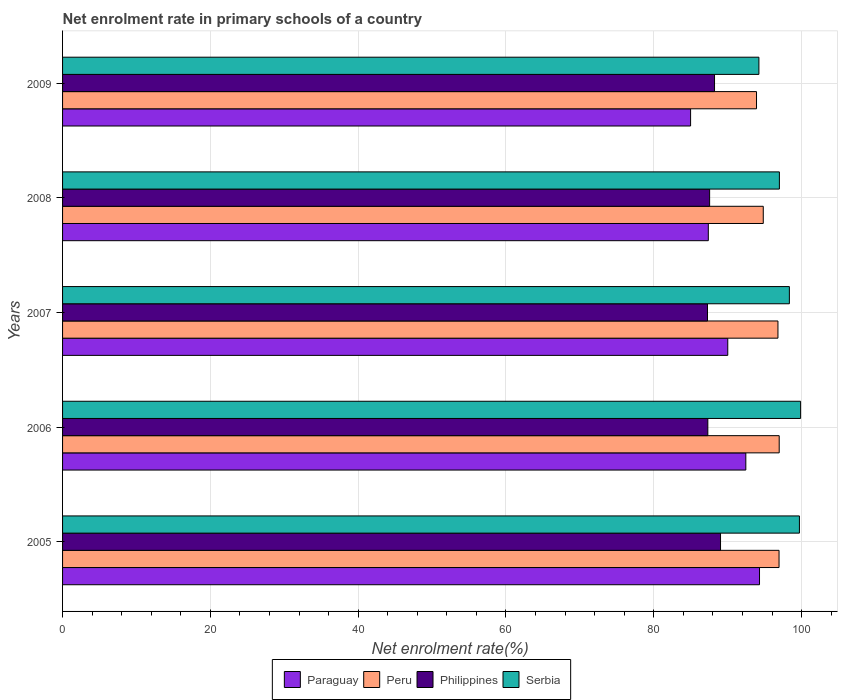Are the number of bars per tick equal to the number of legend labels?
Your answer should be very brief. Yes. How many bars are there on the 3rd tick from the bottom?
Your response must be concise. 4. In how many cases, is the number of bars for a given year not equal to the number of legend labels?
Give a very brief answer. 0. What is the net enrolment rate in primary schools in Peru in 2007?
Your answer should be very brief. 96.8. Across all years, what is the maximum net enrolment rate in primary schools in Paraguay?
Offer a very short reply. 94.3. Across all years, what is the minimum net enrolment rate in primary schools in Philippines?
Your answer should be compact. 87.27. In which year was the net enrolment rate in primary schools in Paraguay maximum?
Offer a terse response. 2005. What is the total net enrolment rate in primary schools in Peru in the graph?
Give a very brief answer. 479.43. What is the difference between the net enrolment rate in primary schools in Philippines in 2005 and that in 2008?
Offer a very short reply. 1.47. What is the difference between the net enrolment rate in primary schools in Peru in 2005 and the net enrolment rate in primary schools in Philippines in 2008?
Provide a short and direct response. 9.39. What is the average net enrolment rate in primary schools in Paraguay per year?
Offer a terse response. 89.82. In the year 2006, what is the difference between the net enrolment rate in primary schools in Paraguay and net enrolment rate in primary schools in Peru?
Your response must be concise. -4.51. What is the ratio of the net enrolment rate in primary schools in Paraguay in 2006 to that in 2008?
Provide a succinct answer. 1.06. Is the difference between the net enrolment rate in primary schools in Paraguay in 2005 and 2006 greater than the difference between the net enrolment rate in primary schools in Peru in 2005 and 2006?
Offer a terse response. Yes. What is the difference between the highest and the second highest net enrolment rate in primary schools in Philippines?
Provide a short and direct response. 0.81. What is the difference between the highest and the lowest net enrolment rate in primary schools in Paraguay?
Offer a very short reply. 9.32. What does the 4th bar from the top in 2009 represents?
Your answer should be very brief. Paraguay. Is it the case that in every year, the sum of the net enrolment rate in primary schools in Philippines and net enrolment rate in primary schools in Paraguay is greater than the net enrolment rate in primary schools in Serbia?
Keep it short and to the point. Yes. How many bars are there?
Your response must be concise. 20. What is the difference between two consecutive major ticks on the X-axis?
Keep it short and to the point. 20. Does the graph contain any zero values?
Offer a terse response. No. Does the graph contain grids?
Your response must be concise. Yes. How many legend labels are there?
Make the answer very short. 4. What is the title of the graph?
Offer a terse response. Net enrolment rate in primary schools of a country. What is the label or title of the X-axis?
Offer a terse response. Net enrolment rate(%). What is the label or title of the Y-axis?
Your answer should be very brief. Years. What is the Net enrolment rate(%) in Paraguay in 2005?
Ensure brevity in your answer.  94.3. What is the Net enrolment rate(%) in Peru in 2005?
Your answer should be very brief. 96.95. What is the Net enrolment rate(%) in Philippines in 2005?
Give a very brief answer. 89.03. What is the Net enrolment rate(%) in Serbia in 2005?
Provide a short and direct response. 99.7. What is the Net enrolment rate(%) in Paraguay in 2006?
Offer a terse response. 92.45. What is the Net enrolment rate(%) of Peru in 2006?
Provide a short and direct response. 96.97. What is the Net enrolment rate(%) in Philippines in 2006?
Offer a very short reply. 87.31. What is the Net enrolment rate(%) in Serbia in 2006?
Your response must be concise. 99.86. What is the Net enrolment rate(%) of Paraguay in 2007?
Your response must be concise. 90.01. What is the Net enrolment rate(%) in Peru in 2007?
Provide a succinct answer. 96.8. What is the Net enrolment rate(%) in Philippines in 2007?
Ensure brevity in your answer.  87.27. What is the Net enrolment rate(%) in Serbia in 2007?
Ensure brevity in your answer.  98.34. What is the Net enrolment rate(%) in Paraguay in 2008?
Keep it short and to the point. 87.38. What is the Net enrolment rate(%) of Peru in 2008?
Offer a very short reply. 94.81. What is the Net enrolment rate(%) in Philippines in 2008?
Offer a terse response. 87.55. What is the Net enrolment rate(%) of Serbia in 2008?
Provide a short and direct response. 96.99. What is the Net enrolment rate(%) in Paraguay in 2009?
Give a very brief answer. 84.98. What is the Net enrolment rate(%) of Peru in 2009?
Keep it short and to the point. 93.9. What is the Net enrolment rate(%) of Philippines in 2009?
Your response must be concise. 88.22. What is the Net enrolment rate(%) in Serbia in 2009?
Provide a short and direct response. 94.22. Across all years, what is the maximum Net enrolment rate(%) of Paraguay?
Your response must be concise. 94.3. Across all years, what is the maximum Net enrolment rate(%) of Peru?
Ensure brevity in your answer.  96.97. Across all years, what is the maximum Net enrolment rate(%) in Philippines?
Keep it short and to the point. 89.03. Across all years, what is the maximum Net enrolment rate(%) in Serbia?
Give a very brief answer. 99.86. Across all years, what is the minimum Net enrolment rate(%) of Paraguay?
Give a very brief answer. 84.98. Across all years, what is the minimum Net enrolment rate(%) in Peru?
Provide a succinct answer. 93.9. Across all years, what is the minimum Net enrolment rate(%) of Philippines?
Your response must be concise. 87.27. Across all years, what is the minimum Net enrolment rate(%) in Serbia?
Keep it short and to the point. 94.22. What is the total Net enrolment rate(%) in Paraguay in the graph?
Offer a very short reply. 449.12. What is the total Net enrolment rate(%) of Peru in the graph?
Make the answer very short. 479.43. What is the total Net enrolment rate(%) in Philippines in the graph?
Offer a very short reply. 439.38. What is the total Net enrolment rate(%) of Serbia in the graph?
Give a very brief answer. 489.13. What is the difference between the Net enrolment rate(%) of Paraguay in 2005 and that in 2006?
Provide a succinct answer. 1.85. What is the difference between the Net enrolment rate(%) in Peru in 2005 and that in 2006?
Ensure brevity in your answer.  -0.02. What is the difference between the Net enrolment rate(%) in Philippines in 2005 and that in 2006?
Your answer should be very brief. 1.72. What is the difference between the Net enrolment rate(%) of Serbia in 2005 and that in 2006?
Provide a short and direct response. -0.16. What is the difference between the Net enrolment rate(%) in Paraguay in 2005 and that in 2007?
Provide a succinct answer. 4.29. What is the difference between the Net enrolment rate(%) in Peru in 2005 and that in 2007?
Provide a succinct answer. 0.15. What is the difference between the Net enrolment rate(%) of Philippines in 2005 and that in 2007?
Your response must be concise. 1.76. What is the difference between the Net enrolment rate(%) of Serbia in 2005 and that in 2007?
Keep it short and to the point. 1.36. What is the difference between the Net enrolment rate(%) of Paraguay in 2005 and that in 2008?
Ensure brevity in your answer.  6.93. What is the difference between the Net enrolment rate(%) in Peru in 2005 and that in 2008?
Provide a succinct answer. 2.14. What is the difference between the Net enrolment rate(%) of Philippines in 2005 and that in 2008?
Your answer should be very brief. 1.47. What is the difference between the Net enrolment rate(%) in Serbia in 2005 and that in 2008?
Provide a succinct answer. 2.71. What is the difference between the Net enrolment rate(%) of Paraguay in 2005 and that in 2009?
Give a very brief answer. 9.32. What is the difference between the Net enrolment rate(%) in Peru in 2005 and that in 2009?
Make the answer very short. 3.05. What is the difference between the Net enrolment rate(%) of Philippines in 2005 and that in 2009?
Give a very brief answer. 0.81. What is the difference between the Net enrolment rate(%) of Serbia in 2005 and that in 2009?
Offer a very short reply. 5.48. What is the difference between the Net enrolment rate(%) in Paraguay in 2006 and that in 2007?
Offer a terse response. 2.44. What is the difference between the Net enrolment rate(%) of Peru in 2006 and that in 2007?
Give a very brief answer. 0.17. What is the difference between the Net enrolment rate(%) in Philippines in 2006 and that in 2007?
Keep it short and to the point. 0.04. What is the difference between the Net enrolment rate(%) in Serbia in 2006 and that in 2007?
Your response must be concise. 1.52. What is the difference between the Net enrolment rate(%) of Paraguay in 2006 and that in 2008?
Ensure brevity in your answer.  5.08. What is the difference between the Net enrolment rate(%) of Peru in 2006 and that in 2008?
Your answer should be very brief. 2.16. What is the difference between the Net enrolment rate(%) of Philippines in 2006 and that in 2008?
Ensure brevity in your answer.  -0.24. What is the difference between the Net enrolment rate(%) of Serbia in 2006 and that in 2008?
Give a very brief answer. 2.87. What is the difference between the Net enrolment rate(%) in Paraguay in 2006 and that in 2009?
Provide a short and direct response. 7.47. What is the difference between the Net enrolment rate(%) in Peru in 2006 and that in 2009?
Provide a succinct answer. 3.07. What is the difference between the Net enrolment rate(%) in Philippines in 2006 and that in 2009?
Your response must be concise. -0.91. What is the difference between the Net enrolment rate(%) of Serbia in 2006 and that in 2009?
Offer a very short reply. 5.64. What is the difference between the Net enrolment rate(%) in Paraguay in 2007 and that in 2008?
Your answer should be compact. 2.63. What is the difference between the Net enrolment rate(%) in Peru in 2007 and that in 2008?
Offer a terse response. 1.99. What is the difference between the Net enrolment rate(%) of Philippines in 2007 and that in 2008?
Keep it short and to the point. -0.29. What is the difference between the Net enrolment rate(%) in Serbia in 2007 and that in 2008?
Keep it short and to the point. 1.35. What is the difference between the Net enrolment rate(%) of Paraguay in 2007 and that in 2009?
Your answer should be compact. 5.03. What is the difference between the Net enrolment rate(%) of Peru in 2007 and that in 2009?
Keep it short and to the point. 2.9. What is the difference between the Net enrolment rate(%) in Philippines in 2007 and that in 2009?
Ensure brevity in your answer.  -0.95. What is the difference between the Net enrolment rate(%) in Serbia in 2007 and that in 2009?
Your response must be concise. 4.12. What is the difference between the Net enrolment rate(%) in Paraguay in 2008 and that in 2009?
Give a very brief answer. 2.4. What is the difference between the Net enrolment rate(%) of Peru in 2008 and that in 2009?
Give a very brief answer. 0.91. What is the difference between the Net enrolment rate(%) of Philippines in 2008 and that in 2009?
Provide a short and direct response. -0.66. What is the difference between the Net enrolment rate(%) in Serbia in 2008 and that in 2009?
Your answer should be very brief. 2.77. What is the difference between the Net enrolment rate(%) in Paraguay in 2005 and the Net enrolment rate(%) in Peru in 2006?
Offer a terse response. -2.66. What is the difference between the Net enrolment rate(%) in Paraguay in 2005 and the Net enrolment rate(%) in Philippines in 2006?
Your response must be concise. 6.99. What is the difference between the Net enrolment rate(%) of Paraguay in 2005 and the Net enrolment rate(%) of Serbia in 2006?
Offer a terse response. -5.56. What is the difference between the Net enrolment rate(%) of Peru in 2005 and the Net enrolment rate(%) of Philippines in 2006?
Make the answer very short. 9.64. What is the difference between the Net enrolment rate(%) of Peru in 2005 and the Net enrolment rate(%) of Serbia in 2006?
Make the answer very short. -2.91. What is the difference between the Net enrolment rate(%) in Philippines in 2005 and the Net enrolment rate(%) in Serbia in 2006?
Ensure brevity in your answer.  -10.83. What is the difference between the Net enrolment rate(%) in Paraguay in 2005 and the Net enrolment rate(%) in Peru in 2007?
Your answer should be compact. -2.49. What is the difference between the Net enrolment rate(%) of Paraguay in 2005 and the Net enrolment rate(%) of Philippines in 2007?
Offer a very short reply. 7.04. What is the difference between the Net enrolment rate(%) in Paraguay in 2005 and the Net enrolment rate(%) in Serbia in 2007?
Make the answer very short. -4.04. What is the difference between the Net enrolment rate(%) in Peru in 2005 and the Net enrolment rate(%) in Philippines in 2007?
Offer a terse response. 9.68. What is the difference between the Net enrolment rate(%) in Peru in 2005 and the Net enrolment rate(%) in Serbia in 2007?
Your answer should be very brief. -1.4. What is the difference between the Net enrolment rate(%) of Philippines in 2005 and the Net enrolment rate(%) of Serbia in 2007?
Make the answer very short. -9.32. What is the difference between the Net enrolment rate(%) of Paraguay in 2005 and the Net enrolment rate(%) of Peru in 2008?
Keep it short and to the point. -0.51. What is the difference between the Net enrolment rate(%) in Paraguay in 2005 and the Net enrolment rate(%) in Philippines in 2008?
Your answer should be compact. 6.75. What is the difference between the Net enrolment rate(%) in Paraguay in 2005 and the Net enrolment rate(%) in Serbia in 2008?
Provide a succinct answer. -2.69. What is the difference between the Net enrolment rate(%) of Peru in 2005 and the Net enrolment rate(%) of Philippines in 2008?
Your answer should be very brief. 9.39. What is the difference between the Net enrolment rate(%) in Peru in 2005 and the Net enrolment rate(%) in Serbia in 2008?
Your answer should be very brief. -0.05. What is the difference between the Net enrolment rate(%) in Philippines in 2005 and the Net enrolment rate(%) in Serbia in 2008?
Offer a terse response. -7.97. What is the difference between the Net enrolment rate(%) of Paraguay in 2005 and the Net enrolment rate(%) of Peru in 2009?
Offer a very short reply. 0.4. What is the difference between the Net enrolment rate(%) in Paraguay in 2005 and the Net enrolment rate(%) in Philippines in 2009?
Your answer should be compact. 6.09. What is the difference between the Net enrolment rate(%) in Paraguay in 2005 and the Net enrolment rate(%) in Serbia in 2009?
Offer a terse response. 0.08. What is the difference between the Net enrolment rate(%) of Peru in 2005 and the Net enrolment rate(%) of Philippines in 2009?
Ensure brevity in your answer.  8.73. What is the difference between the Net enrolment rate(%) of Peru in 2005 and the Net enrolment rate(%) of Serbia in 2009?
Provide a short and direct response. 2.72. What is the difference between the Net enrolment rate(%) of Philippines in 2005 and the Net enrolment rate(%) of Serbia in 2009?
Keep it short and to the point. -5.19. What is the difference between the Net enrolment rate(%) in Paraguay in 2006 and the Net enrolment rate(%) in Peru in 2007?
Your answer should be very brief. -4.35. What is the difference between the Net enrolment rate(%) in Paraguay in 2006 and the Net enrolment rate(%) in Philippines in 2007?
Provide a short and direct response. 5.19. What is the difference between the Net enrolment rate(%) in Paraguay in 2006 and the Net enrolment rate(%) in Serbia in 2007?
Your answer should be very brief. -5.89. What is the difference between the Net enrolment rate(%) in Peru in 2006 and the Net enrolment rate(%) in Philippines in 2007?
Offer a terse response. 9.7. What is the difference between the Net enrolment rate(%) in Peru in 2006 and the Net enrolment rate(%) in Serbia in 2007?
Offer a very short reply. -1.38. What is the difference between the Net enrolment rate(%) of Philippines in 2006 and the Net enrolment rate(%) of Serbia in 2007?
Give a very brief answer. -11.03. What is the difference between the Net enrolment rate(%) of Paraguay in 2006 and the Net enrolment rate(%) of Peru in 2008?
Your response must be concise. -2.36. What is the difference between the Net enrolment rate(%) of Paraguay in 2006 and the Net enrolment rate(%) of Philippines in 2008?
Your answer should be compact. 4.9. What is the difference between the Net enrolment rate(%) of Paraguay in 2006 and the Net enrolment rate(%) of Serbia in 2008?
Your answer should be very brief. -4.54. What is the difference between the Net enrolment rate(%) of Peru in 2006 and the Net enrolment rate(%) of Philippines in 2008?
Make the answer very short. 9.41. What is the difference between the Net enrolment rate(%) in Peru in 2006 and the Net enrolment rate(%) in Serbia in 2008?
Provide a succinct answer. -0.03. What is the difference between the Net enrolment rate(%) in Philippines in 2006 and the Net enrolment rate(%) in Serbia in 2008?
Your answer should be compact. -9.68. What is the difference between the Net enrolment rate(%) of Paraguay in 2006 and the Net enrolment rate(%) of Peru in 2009?
Make the answer very short. -1.45. What is the difference between the Net enrolment rate(%) of Paraguay in 2006 and the Net enrolment rate(%) of Philippines in 2009?
Offer a terse response. 4.23. What is the difference between the Net enrolment rate(%) in Paraguay in 2006 and the Net enrolment rate(%) in Serbia in 2009?
Make the answer very short. -1.77. What is the difference between the Net enrolment rate(%) of Peru in 2006 and the Net enrolment rate(%) of Philippines in 2009?
Make the answer very short. 8.75. What is the difference between the Net enrolment rate(%) of Peru in 2006 and the Net enrolment rate(%) of Serbia in 2009?
Give a very brief answer. 2.74. What is the difference between the Net enrolment rate(%) of Philippines in 2006 and the Net enrolment rate(%) of Serbia in 2009?
Ensure brevity in your answer.  -6.91. What is the difference between the Net enrolment rate(%) in Paraguay in 2007 and the Net enrolment rate(%) in Peru in 2008?
Keep it short and to the point. -4.8. What is the difference between the Net enrolment rate(%) in Paraguay in 2007 and the Net enrolment rate(%) in Philippines in 2008?
Provide a succinct answer. 2.45. What is the difference between the Net enrolment rate(%) in Paraguay in 2007 and the Net enrolment rate(%) in Serbia in 2008?
Your response must be concise. -6.99. What is the difference between the Net enrolment rate(%) of Peru in 2007 and the Net enrolment rate(%) of Philippines in 2008?
Ensure brevity in your answer.  9.24. What is the difference between the Net enrolment rate(%) in Peru in 2007 and the Net enrolment rate(%) in Serbia in 2008?
Ensure brevity in your answer.  -0.2. What is the difference between the Net enrolment rate(%) in Philippines in 2007 and the Net enrolment rate(%) in Serbia in 2008?
Provide a succinct answer. -9.73. What is the difference between the Net enrolment rate(%) of Paraguay in 2007 and the Net enrolment rate(%) of Peru in 2009?
Ensure brevity in your answer.  -3.89. What is the difference between the Net enrolment rate(%) of Paraguay in 2007 and the Net enrolment rate(%) of Philippines in 2009?
Your answer should be compact. 1.79. What is the difference between the Net enrolment rate(%) in Paraguay in 2007 and the Net enrolment rate(%) in Serbia in 2009?
Ensure brevity in your answer.  -4.21. What is the difference between the Net enrolment rate(%) in Peru in 2007 and the Net enrolment rate(%) in Philippines in 2009?
Provide a short and direct response. 8.58. What is the difference between the Net enrolment rate(%) in Peru in 2007 and the Net enrolment rate(%) in Serbia in 2009?
Give a very brief answer. 2.58. What is the difference between the Net enrolment rate(%) of Philippines in 2007 and the Net enrolment rate(%) of Serbia in 2009?
Give a very brief answer. -6.96. What is the difference between the Net enrolment rate(%) in Paraguay in 2008 and the Net enrolment rate(%) in Peru in 2009?
Your answer should be compact. -6.52. What is the difference between the Net enrolment rate(%) of Paraguay in 2008 and the Net enrolment rate(%) of Philippines in 2009?
Provide a short and direct response. -0.84. What is the difference between the Net enrolment rate(%) in Paraguay in 2008 and the Net enrolment rate(%) in Serbia in 2009?
Give a very brief answer. -6.85. What is the difference between the Net enrolment rate(%) in Peru in 2008 and the Net enrolment rate(%) in Philippines in 2009?
Your answer should be very brief. 6.59. What is the difference between the Net enrolment rate(%) in Peru in 2008 and the Net enrolment rate(%) in Serbia in 2009?
Give a very brief answer. 0.59. What is the difference between the Net enrolment rate(%) in Philippines in 2008 and the Net enrolment rate(%) in Serbia in 2009?
Keep it short and to the point. -6.67. What is the average Net enrolment rate(%) of Paraguay per year?
Provide a short and direct response. 89.82. What is the average Net enrolment rate(%) in Peru per year?
Provide a succinct answer. 95.89. What is the average Net enrolment rate(%) in Philippines per year?
Keep it short and to the point. 87.88. What is the average Net enrolment rate(%) of Serbia per year?
Keep it short and to the point. 97.83. In the year 2005, what is the difference between the Net enrolment rate(%) of Paraguay and Net enrolment rate(%) of Peru?
Offer a terse response. -2.64. In the year 2005, what is the difference between the Net enrolment rate(%) of Paraguay and Net enrolment rate(%) of Philippines?
Make the answer very short. 5.27. In the year 2005, what is the difference between the Net enrolment rate(%) in Paraguay and Net enrolment rate(%) in Serbia?
Your answer should be very brief. -5.4. In the year 2005, what is the difference between the Net enrolment rate(%) of Peru and Net enrolment rate(%) of Philippines?
Give a very brief answer. 7.92. In the year 2005, what is the difference between the Net enrolment rate(%) of Peru and Net enrolment rate(%) of Serbia?
Ensure brevity in your answer.  -2.76. In the year 2005, what is the difference between the Net enrolment rate(%) in Philippines and Net enrolment rate(%) in Serbia?
Give a very brief answer. -10.67. In the year 2006, what is the difference between the Net enrolment rate(%) of Paraguay and Net enrolment rate(%) of Peru?
Offer a terse response. -4.51. In the year 2006, what is the difference between the Net enrolment rate(%) in Paraguay and Net enrolment rate(%) in Philippines?
Offer a very short reply. 5.14. In the year 2006, what is the difference between the Net enrolment rate(%) of Paraguay and Net enrolment rate(%) of Serbia?
Ensure brevity in your answer.  -7.41. In the year 2006, what is the difference between the Net enrolment rate(%) of Peru and Net enrolment rate(%) of Philippines?
Keep it short and to the point. 9.66. In the year 2006, what is the difference between the Net enrolment rate(%) in Peru and Net enrolment rate(%) in Serbia?
Provide a succinct answer. -2.89. In the year 2006, what is the difference between the Net enrolment rate(%) of Philippines and Net enrolment rate(%) of Serbia?
Offer a terse response. -12.55. In the year 2007, what is the difference between the Net enrolment rate(%) in Paraguay and Net enrolment rate(%) in Peru?
Make the answer very short. -6.79. In the year 2007, what is the difference between the Net enrolment rate(%) in Paraguay and Net enrolment rate(%) in Philippines?
Offer a very short reply. 2.74. In the year 2007, what is the difference between the Net enrolment rate(%) of Paraguay and Net enrolment rate(%) of Serbia?
Keep it short and to the point. -8.34. In the year 2007, what is the difference between the Net enrolment rate(%) in Peru and Net enrolment rate(%) in Philippines?
Make the answer very short. 9.53. In the year 2007, what is the difference between the Net enrolment rate(%) of Peru and Net enrolment rate(%) of Serbia?
Make the answer very short. -1.55. In the year 2007, what is the difference between the Net enrolment rate(%) in Philippines and Net enrolment rate(%) in Serbia?
Keep it short and to the point. -11.08. In the year 2008, what is the difference between the Net enrolment rate(%) in Paraguay and Net enrolment rate(%) in Peru?
Make the answer very short. -7.44. In the year 2008, what is the difference between the Net enrolment rate(%) in Paraguay and Net enrolment rate(%) in Philippines?
Your response must be concise. -0.18. In the year 2008, what is the difference between the Net enrolment rate(%) in Paraguay and Net enrolment rate(%) in Serbia?
Provide a succinct answer. -9.62. In the year 2008, what is the difference between the Net enrolment rate(%) of Peru and Net enrolment rate(%) of Philippines?
Offer a very short reply. 7.26. In the year 2008, what is the difference between the Net enrolment rate(%) in Peru and Net enrolment rate(%) in Serbia?
Keep it short and to the point. -2.18. In the year 2008, what is the difference between the Net enrolment rate(%) of Philippines and Net enrolment rate(%) of Serbia?
Your answer should be compact. -9.44. In the year 2009, what is the difference between the Net enrolment rate(%) in Paraguay and Net enrolment rate(%) in Peru?
Offer a terse response. -8.92. In the year 2009, what is the difference between the Net enrolment rate(%) of Paraguay and Net enrolment rate(%) of Philippines?
Provide a succinct answer. -3.24. In the year 2009, what is the difference between the Net enrolment rate(%) of Paraguay and Net enrolment rate(%) of Serbia?
Ensure brevity in your answer.  -9.24. In the year 2009, what is the difference between the Net enrolment rate(%) in Peru and Net enrolment rate(%) in Philippines?
Your answer should be very brief. 5.68. In the year 2009, what is the difference between the Net enrolment rate(%) in Peru and Net enrolment rate(%) in Serbia?
Your answer should be compact. -0.32. In the year 2009, what is the difference between the Net enrolment rate(%) of Philippines and Net enrolment rate(%) of Serbia?
Your answer should be very brief. -6. What is the ratio of the Net enrolment rate(%) of Peru in 2005 to that in 2006?
Your response must be concise. 1. What is the ratio of the Net enrolment rate(%) in Philippines in 2005 to that in 2006?
Your answer should be compact. 1.02. What is the ratio of the Net enrolment rate(%) of Serbia in 2005 to that in 2006?
Your answer should be very brief. 1. What is the ratio of the Net enrolment rate(%) of Paraguay in 2005 to that in 2007?
Your answer should be compact. 1.05. What is the ratio of the Net enrolment rate(%) of Peru in 2005 to that in 2007?
Your answer should be compact. 1. What is the ratio of the Net enrolment rate(%) in Philippines in 2005 to that in 2007?
Provide a succinct answer. 1.02. What is the ratio of the Net enrolment rate(%) in Serbia in 2005 to that in 2007?
Give a very brief answer. 1.01. What is the ratio of the Net enrolment rate(%) in Paraguay in 2005 to that in 2008?
Your answer should be very brief. 1.08. What is the ratio of the Net enrolment rate(%) in Peru in 2005 to that in 2008?
Offer a terse response. 1.02. What is the ratio of the Net enrolment rate(%) of Philippines in 2005 to that in 2008?
Your answer should be very brief. 1.02. What is the ratio of the Net enrolment rate(%) in Serbia in 2005 to that in 2008?
Your answer should be very brief. 1.03. What is the ratio of the Net enrolment rate(%) in Paraguay in 2005 to that in 2009?
Provide a short and direct response. 1.11. What is the ratio of the Net enrolment rate(%) in Peru in 2005 to that in 2009?
Make the answer very short. 1.03. What is the ratio of the Net enrolment rate(%) in Philippines in 2005 to that in 2009?
Your answer should be very brief. 1.01. What is the ratio of the Net enrolment rate(%) in Serbia in 2005 to that in 2009?
Offer a terse response. 1.06. What is the ratio of the Net enrolment rate(%) in Paraguay in 2006 to that in 2007?
Provide a short and direct response. 1.03. What is the ratio of the Net enrolment rate(%) of Peru in 2006 to that in 2007?
Your answer should be compact. 1. What is the ratio of the Net enrolment rate(%) of Philippines in 2006 to that in 2007?
Ensure brevity in your answer.  1. What is the ratio of the Net enrolment rate(%) of Serbia in 2006 to that in 2007?
Ensure brevity in your answer.  1.02. What is the ratio of the Net enrolment rate(%) of Paraguay in 2006 to that in 2008?
Make the answer very short. 1.06. What is the ratio of the Net enrolment rate(%) of Peru in 2006 to that in 2008?
Your answer should be very brief. 1.02. What is the ratio of the Net enrolment rate(%) of Philippines in 2006 to that in 2008?
Provide a short and direct response. 1. What is the ratio of the Net enrolment rate(%) in Serbia in 2006 to that in 2008?
Your response must be concise. 1.03. What is the ratio of the Net enrolment rate(%) in Paraguay in 2006 to that in 2009?
Offer a very short reply. 1.09. What is the ratio of the Net enrolment rate(%) of Peru in 2006 to that in 2009?
Your answer should be compact. 1.03. What is the ratio of the Net enrolment rate(%) of Philippines in 2006 to that in 2009?
Keep it short and to the point. 0.99. What is the ratio of the Net enrolment rate(%) in Serbia in 2006 to that in 2009?
Offer a very short reply. 1.06. What is the ratio of the Net enrolment rate(%) in Paraguay in 2007 to that in 2008?
Make the answer very short. 1.03. What is the ratio of the Net enrolment rate(%) in Peru in 2007 to that in 2008?
Keep it short and to the point. 1.02. What is the ratio of the Net enrolment rate(%) in Serbia in 2007 to that in 2008?
Give a very brief answer. 1.01. What is the ratio of the Net enrolment rate(%) in Paraguay in 2007 to that in 2009?
Offer a terse response. 1.06. What is the ratio of the Net enrolment rate(%) in Peru in 2007 to that in 2009?
Keep it short and to the point. 1.03. What is the ratio of the Net enrolment rate(%) in Philippines in 2007 to that in 2009?
Ensure brevity in your answer.  0.99. What is the ratio of the Net enrolment rate(%) in Serbia in 2007 to that in 2009?
Your response must be concise. 1.04. What is the ratio of the Net enrolment rate(%) of Paraguay in 2008 to that in 2009?
Provide a short and direct response. 1.03. What is the ratio of the Net enrolment rate(%) in Peru in 2008 to that in 2009?
Offer a very short reply. 1.01. What is the ratio of the Net enrolment rate(%) of Philippines in 2008 to that in 2009?
Your answer should be compact. 0.99. What is the ratio of the Net enrolment rate(%) of Serbia in 2008 to that in 2009?
Keep it short and to the point. 1.03. What is the difference between the highest and the second highest Net enrolment rate(%) in Paraguay?
Ensure brevity in your answer.  1.85. What is the difference between the highest and the second highest Net enrolment rate(%) of Peru?
Ensure brevity in your answer.  0.02. What is the difference between the highest and the second highest Net enrolment rate(%) in Philippines?
Give a very brief answer. 0.81. What is the difference between the highest and the second highest Net enrolment rate(%) of Serbia?
Give a very brief answer. 0.16. What is the difference between the highest and the lowest Net enrolment rate(%) of Paraguay?
Offer a terse response. 9.32. What is the difference between the highest and the lowest Net enrolment rate(%) in Peru?
Make the answer very short. 3.07. What is the difference between the highest and the lowest Net enrolment rate(%) of Philippines?
Provide a succinct answer. 1.76. What is the difference between the highest and the lowest Net enrolment rate(%) of Serbia?
Offer a very short reply. 5.64. 